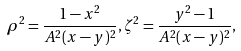<formula> <loc_0><loc_0><loc_500><loc_500>\rho ^ { 2 } = \frac { 1 - x ^ { 2 } } { A ^ { 2 } ( x - y ) ^ { 2 } } , \zeta ^ { 2 } = \frac { y ^ { 2 } - 1 } { A ^ { 2 } ( x - y ) ^ { 2 } } ,</formula> 